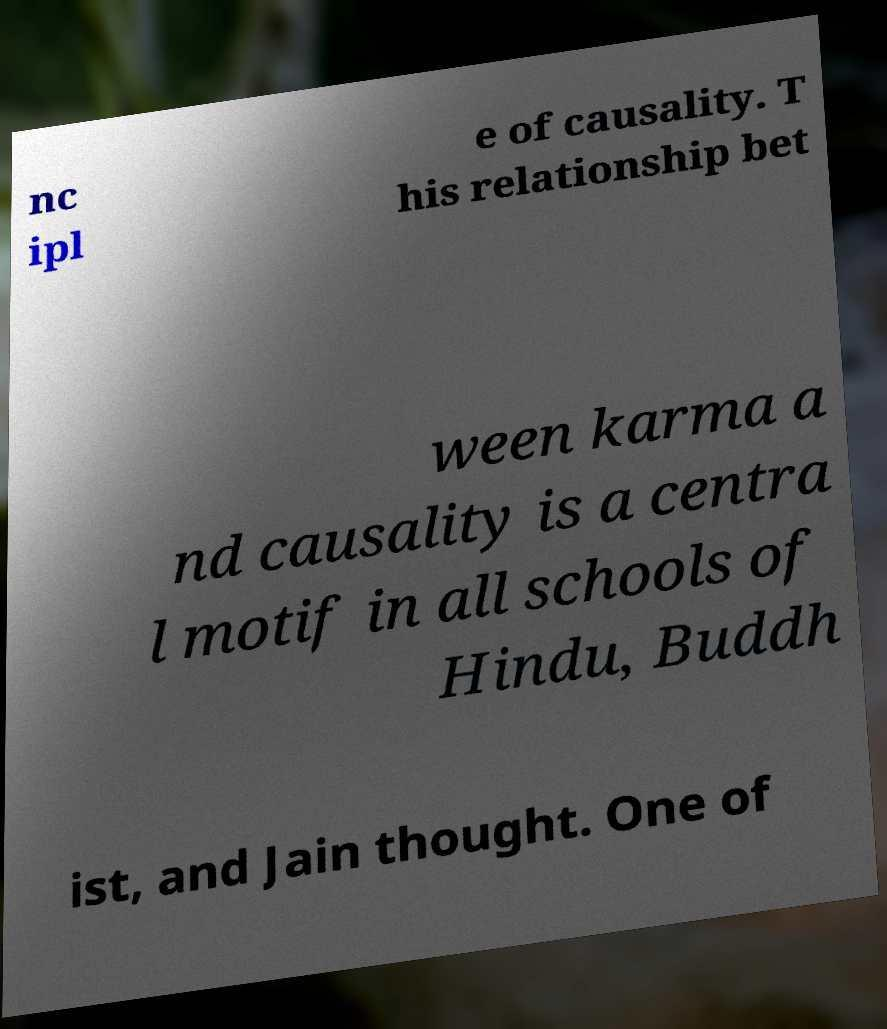For documentation purposes, I need the text within this image transcribed. Could you provide that? nc ipl e of causality. T his relationship bet ween karma a nd causality is a centra l motif in all schools of Hindu, Buddh ist, and Jain thought. One of 